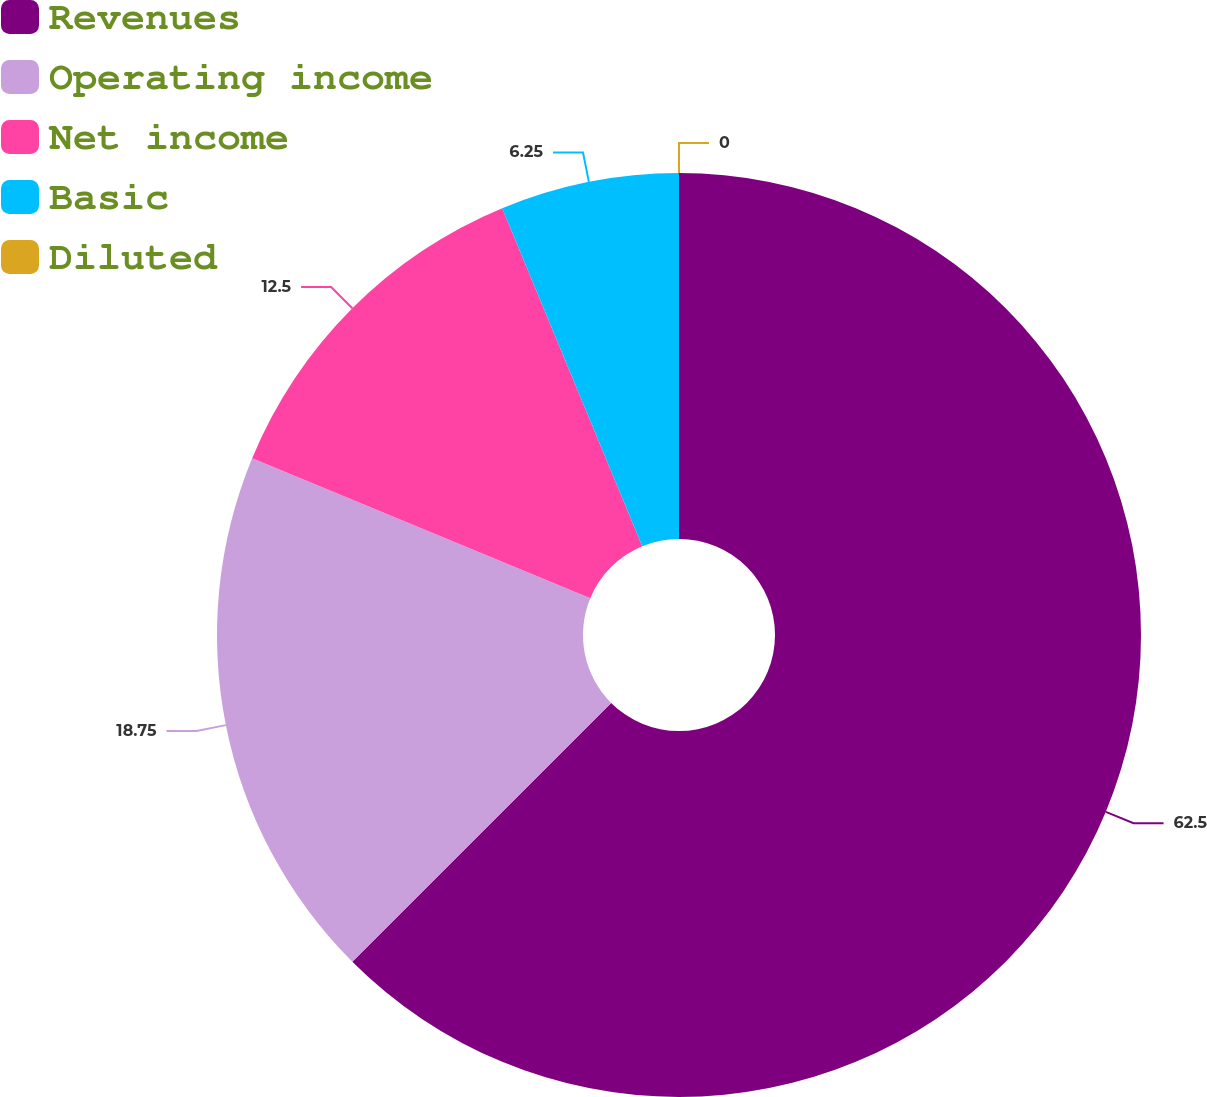<chart> <loc_0><loc_0><loc_500><loc_500><pie_chart><fcel>Revenues<fcel>Operating income<fcel>Net income<fcel>Basic<fcel>Diluted<nl><fcel>62.5%<fcel>18.75%<fcel>12.5%<fcel>6.25%<fcel>0.0%<nl></chart> 